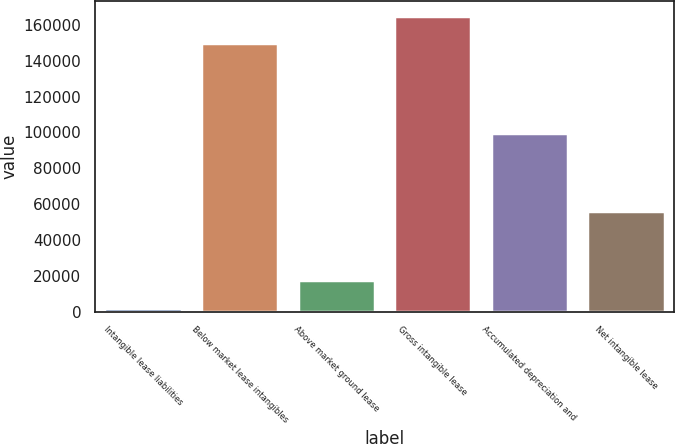<chart> <loc_0><loc_0><loc_500><loc_500><bar_chart><fcel>Intangible lease liabilities<fcel>Below market lease intangibles<fcel>Above market ground lease<fcel>Gross intangible lease<fcel>Accumulated depreciation and<fcel>Net intangible lease<nl><fcel>2015<fcel>149762<fcel>17401.8<fcel>165149<fcel>99736<fcel>56147<nl></chart> 